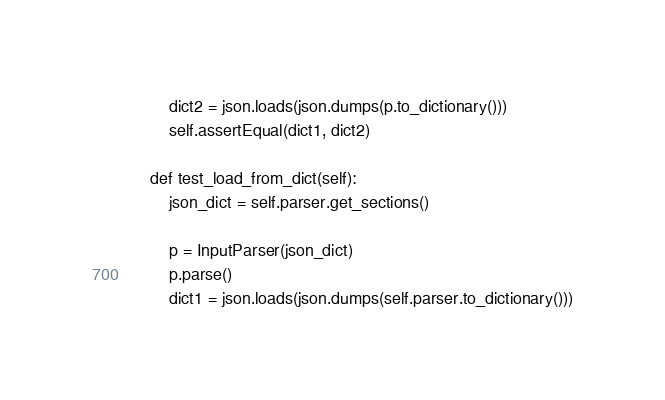<code> <loc_0><loc_0><loc_500><loc_500><_Python_>        dict2 = json.loads(json.dumps(p.to_dictionary()))
        self.assertEqual(dict1, dict2)

    def test_load_from_dict(self):
        json_dict = self.parser.get_sections()

        p = InputParser(json_dict)
        p.parse()
        dict1 = json.loads(json.dumps(self.parser.to_dictionary()))</code> 